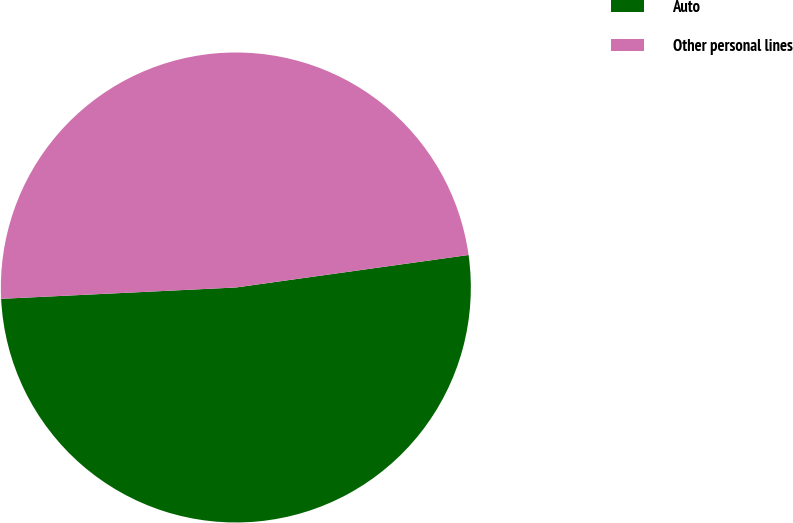Convert chart. <chart><loc_0><loc_0><loc_500><loc_500><pie_chart><fcel>Auto<fcel>Other personal lines<nl><fcel>51.44%<fcel>48.56%<nl></chart> 